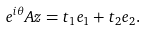Convert formula to latex. <formula><loc_0><loc_0><loc_500><loc_500>e ^ { i \theta } A z = t _ { 1 } e _ { 1 } + t _ { 2 } e _ { 2 } .</formula> 